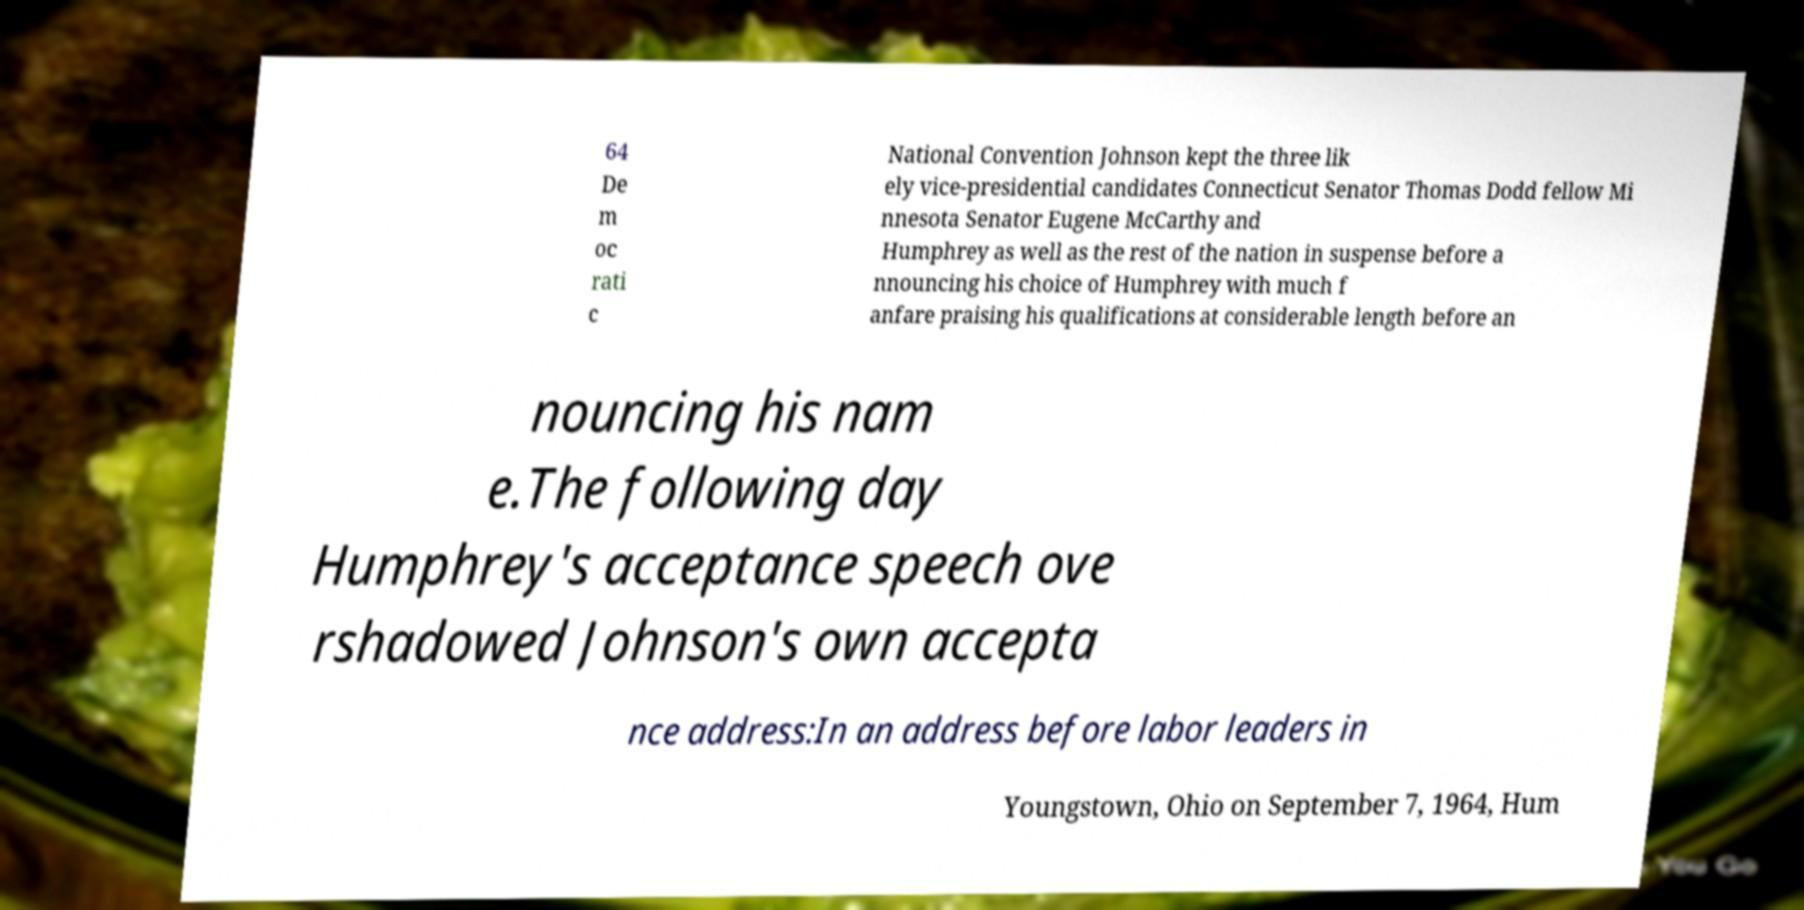For documentation purposes, I need the text within this image transcribed. Could you provide that? 64 De m oc rati c National Convention Johnson kept the three lik ely vice-presidential candidates Connecticut Senator Thomas Dodd fellow Mi nnesota Senator Eugene McCarthy and Humphrey as well as the rest of the nation in suspense before a nnouncing his choice of Humphrey with much f anfare praising his qualifications at considerable length before an nouncing his nam e.The following day Humphrey's acceptance speech ove rshadowed Johnson's own accepta nce address:In an address before labor leaders in Youngstown, Ohio on September 7, 1964, Hum 